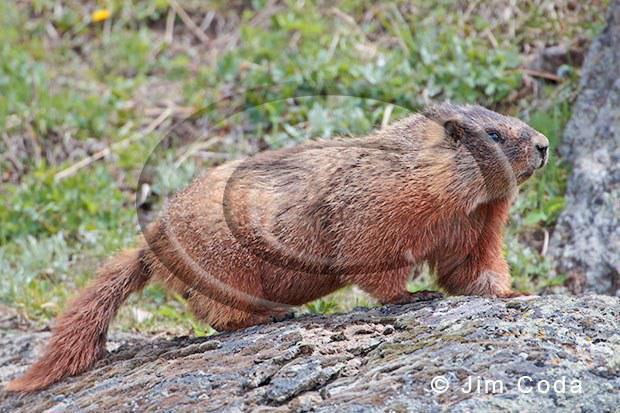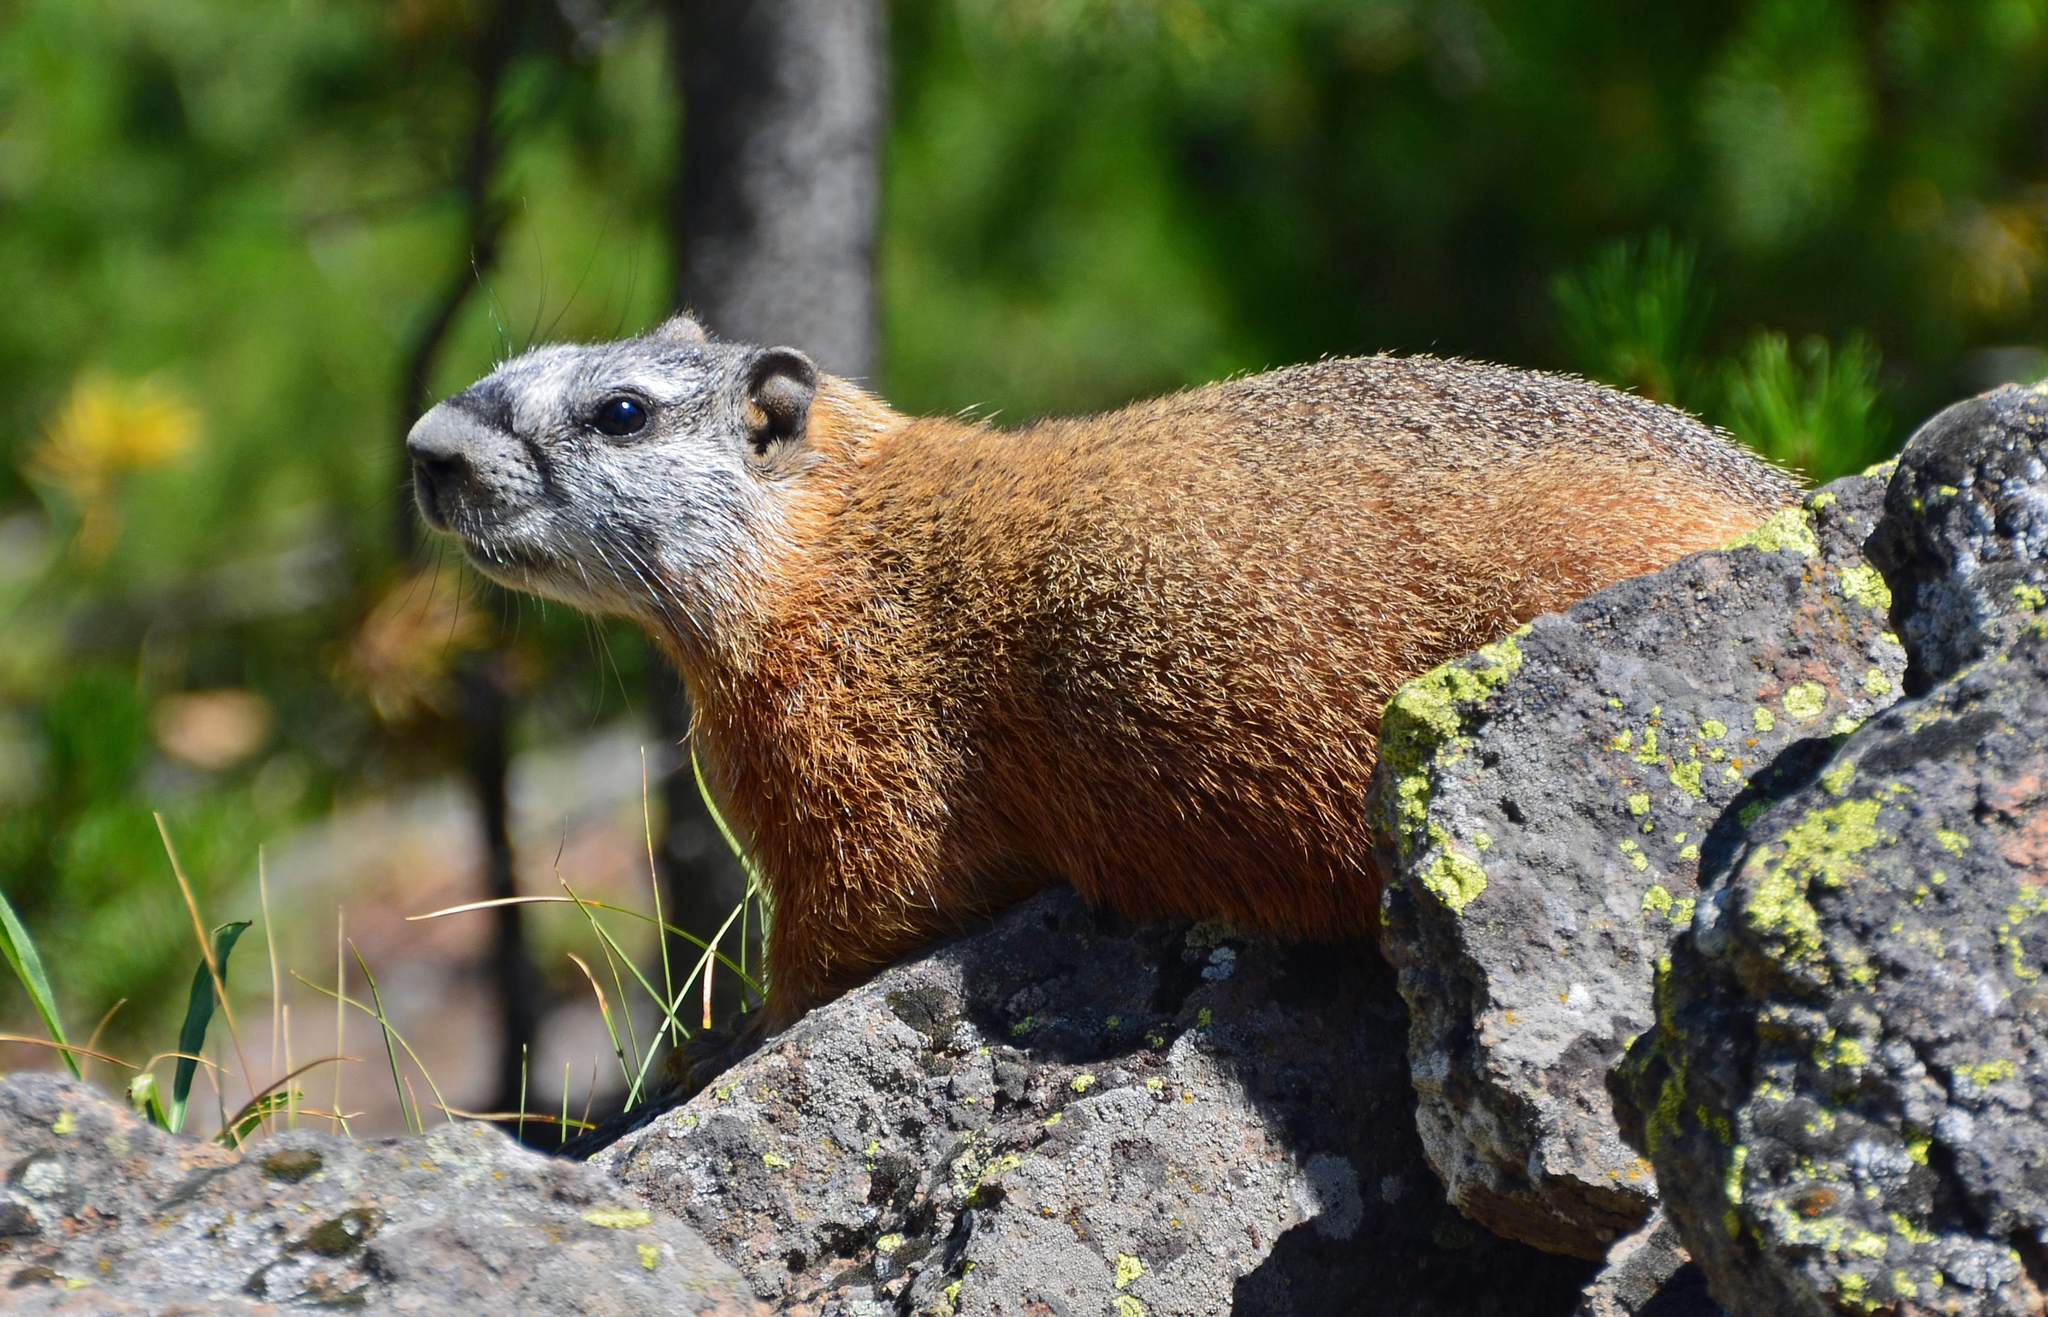The first image is the image on the left, the second image is the image on the right. Assess this claim about the two images: "The animal in the image to the left is clearly much more red than it's paired image.". Correct or not? Answer yes or no. No. The first image is the image on the left, the second image is the image on the right. Examine the images to the left and right. Is the description "The marmots in the two images appear to face each other." accurate? Answer yes or no. Yes. 